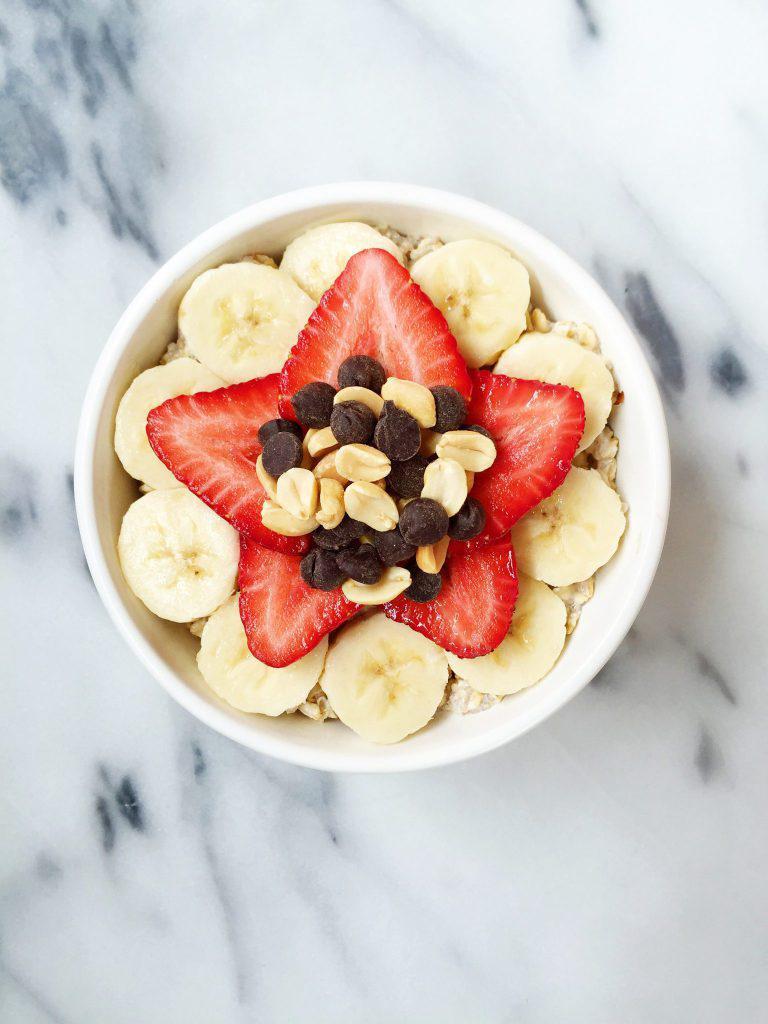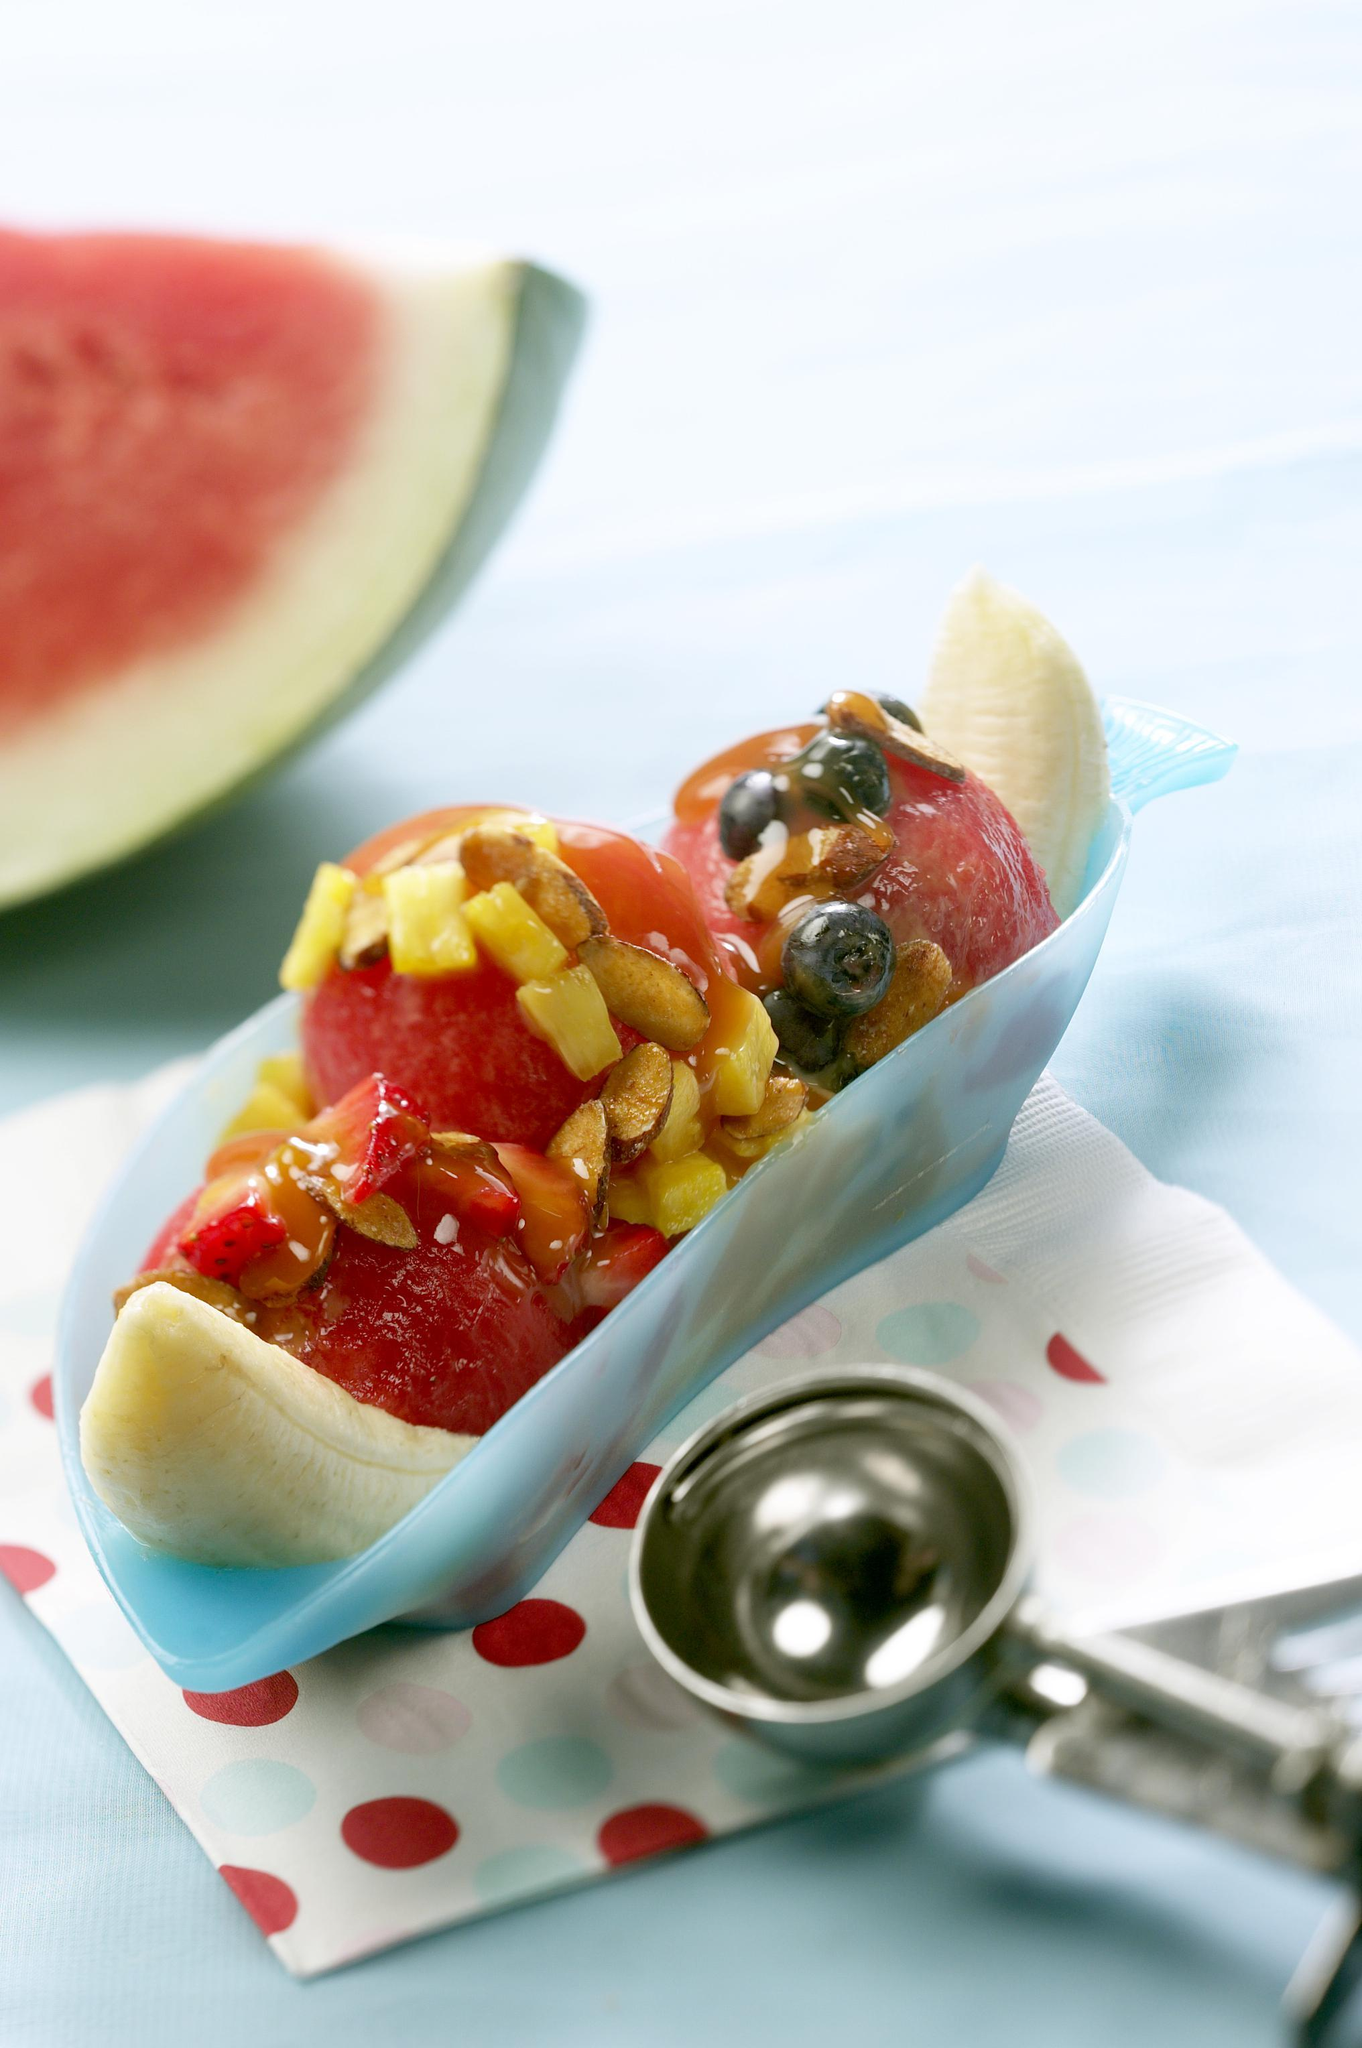The first image is the image on the left, the second image is the image on the right. Evaluate the accuracy of this statement regarding the images: "There are round banana slices.". Is it true? Answer yes or no. Yes. 